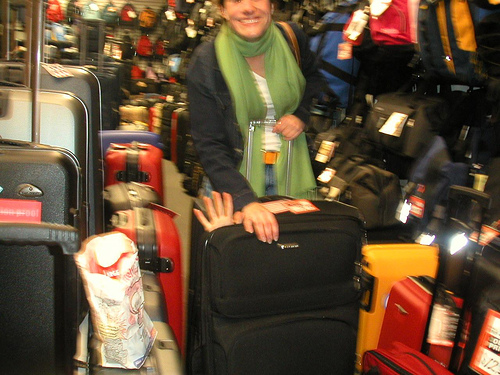What types of luggage can you identify in the photo? The photo showcases a range of luggage options including hard-shell suitcases in various colors, soft-sided roller bags, and at least one backpack on the left. The color palette of the luggage varies from black and gray to vibrant reds, showcasing a diversity in travel gear styles. Can you comment on the lighting and quality of the photograph? The lighting in the photograph is somewhat uneven, which might be due to artificial illumination common in indoor settings and a slightly blurry focus that suggests movement or a quick snapshot. These elements give the image a candid and dynamic feel. 